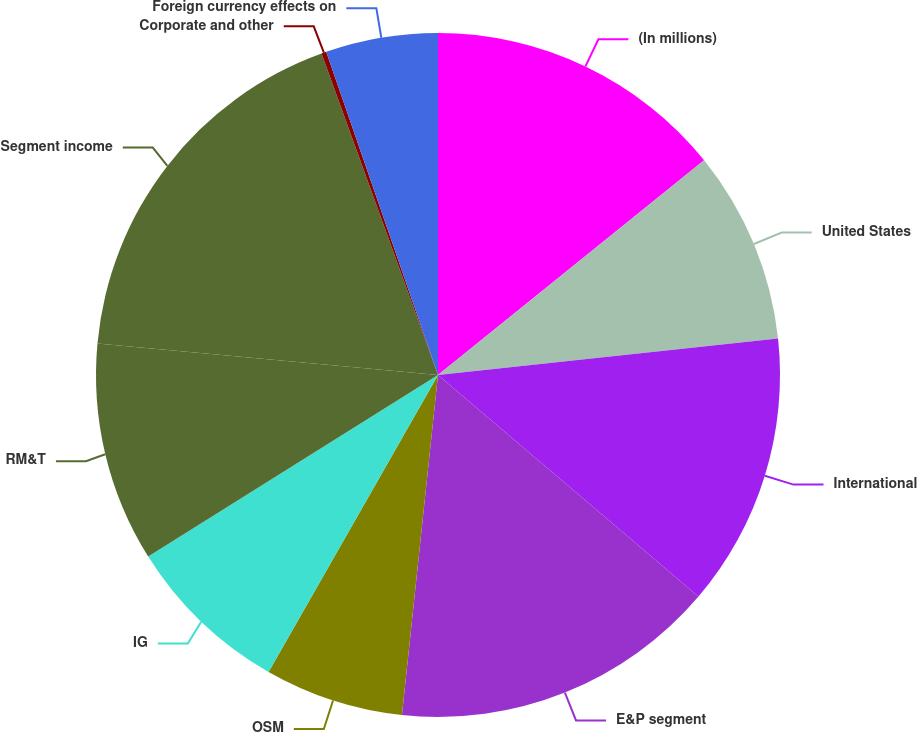<chart> <loc_0><loc_0><loc_500><loc_500><pie_chart><fcel>(In millions)<fcel>United States<fcel>International<fcel>E&P segment<fcel>OSM<fcel>IG<fcel>RM&T<fcel>Segment income<fcel>Corporate and other<fcel>Foreign currency effects on<nl><fcel>14.19%<fcel>9.11%<fcel>12.92%<fcel>15.46%<fcel>6.57%<fcel>7.84%<fcel>10.38%<fcel>18.0%<fcel>0.23%<fcel>5.3%<nl></chart> 